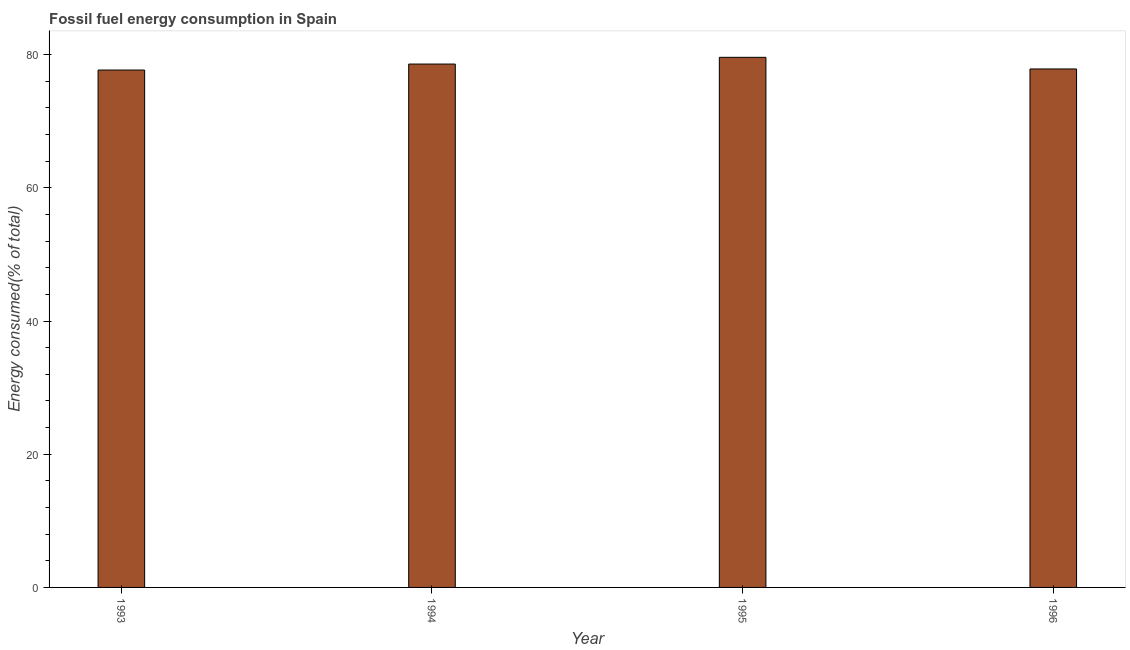Does the graph contain any zero values?
Offer a very short reply. No. Does the graph contain grids?
Your answer should be very brief. No. What is the title of the graph?
Your answer should be compact. Fossil fuel energy consumption in Spain. What is the label or title of the X-axis?
Make the answer very short. Year. What is the label or title of the Y-axis?
Your response must be concise. Energy consumed(% of total). What is the fossil fuel energy consumption in 1994?
Keep it short and to the point. 78.59. Across all years, what is the maximum fossil fuel energy consumption?
Keep it short and to the point. 79.6. Across all years, what is the minimum fossil fuel energy consumption?
Your answer should be compact. 77.69. In which year was the fossil fuel energy consumption minimum?
Ensure brevity in your answer.  1993. What is the sum of the fossil fuel energy consumption?
Your answer should be compact. 313.74. What is the difference between the fossil fuel energy consumption in 1993 and 1996?
Keep it short and to the point. -0.16. What is the average fossil fuel energy consumption per year?
Provide a succinct answer. 78.43. What is the median fossil fuel energy consumption?
Keep it short and to the point. 78.22. In how many years, is the fossil fuel energy consumption greater than 16 %?
Offer a very short reply. 4. Do a majority of the years between 1993 and 1994 (inclusive) have fossil fuel energy consumption greater than 60 %?
Offer a very short reply. Yes. Is the fossil fuel energy consumption in 1994 less than that in 1996?
Make the answer very short. No. What is the difference between the highest and the lowest fossil fuel energy consumption?
Offer a terse response. 1.91. Are the values on the major ticks of Y-axis written in scientific E-notation?
Your response must be concise. No. What is the Energy consumed(% of total) of 1993?
Offer a terse response. 77.69. What is the Energy consumed(% of total) of 1994?
Offer a terse response. 78.59. What is the Energy consumed(% of total) in 1995?
Offer a terse response. 79.6. What is the Energy consumed(% of total) of 1996?
Provide a succinct answer. 77.85. What is the difference between the Energy consumed(% of total) in 1993 and 1994?
Make the answer very short. -0.9. What is the difference between the Energy consumed(% of total) in 1993 and 1995?
Keep it short and to the point. -1.91. What is the difference between the Energy consumed(% of total) in 1993 and 1996?
Make the answer very short. -0.16. What is the difference between the Energy consumed(% of total) in 1994 and 1995?
Your answer should be compact. -1.01. What is the difference between the Energy consumed(% of total) in 1994 and 1996?
Make the answer very short. 0.74. What is the difference between the Energy consumed(% of total) in 1995 and 1996?
Give a very brief answer. 1.75. What is the ratio of the Energy consumed(% of total) in 1993 to that in 1994?
Your response must be concise. 0.99. What is the ratio of the Energy consumed(% of total) in 1993 to that in 1995?
Your answer should be very brief. 0.98. What is the ratio of the Energy consumed(% of total) in 1995 to that in 1996?
Offer a very short reply. 1.02. 